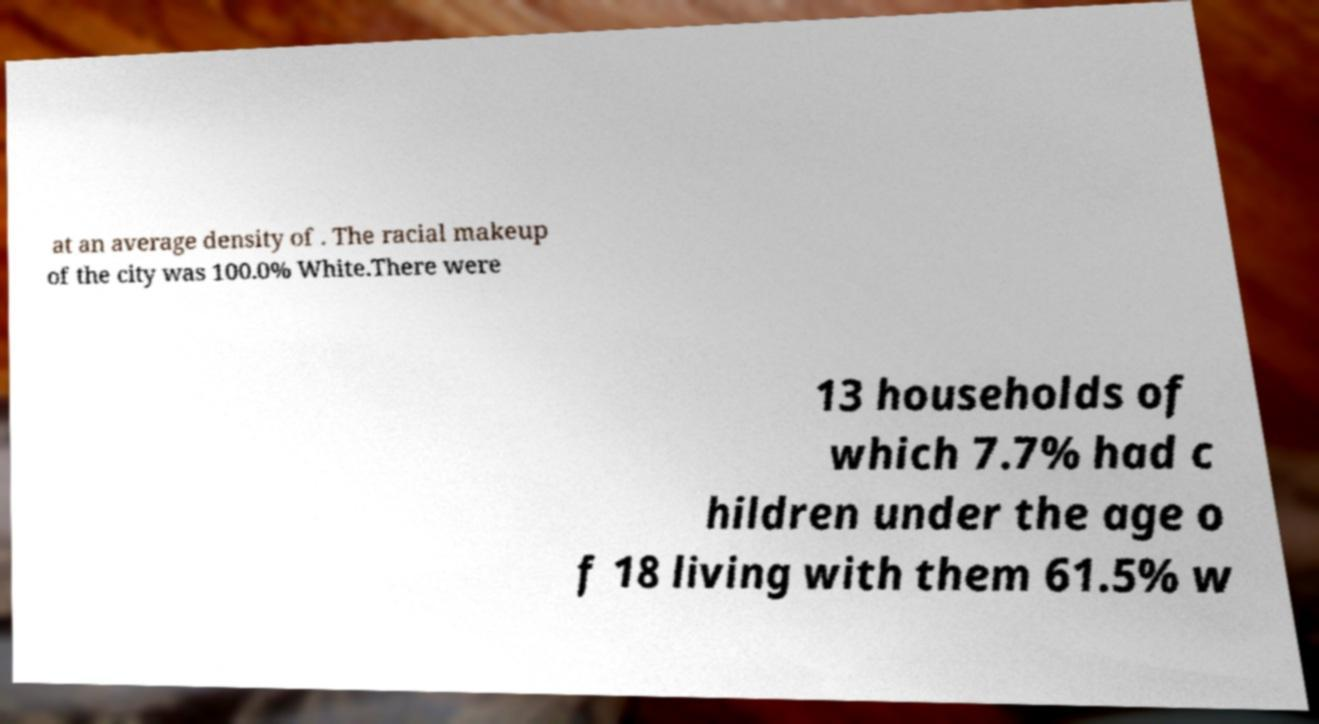Can you read and provide the text displayed in the image?This photo seems to have some interesting text. Can you extract and type it out for me? at an average density of . The racial makeup of the city was 100.0% White.There were 13 households of which 7.7% had c hildren under the age o f 18 living with them 61.5% w 